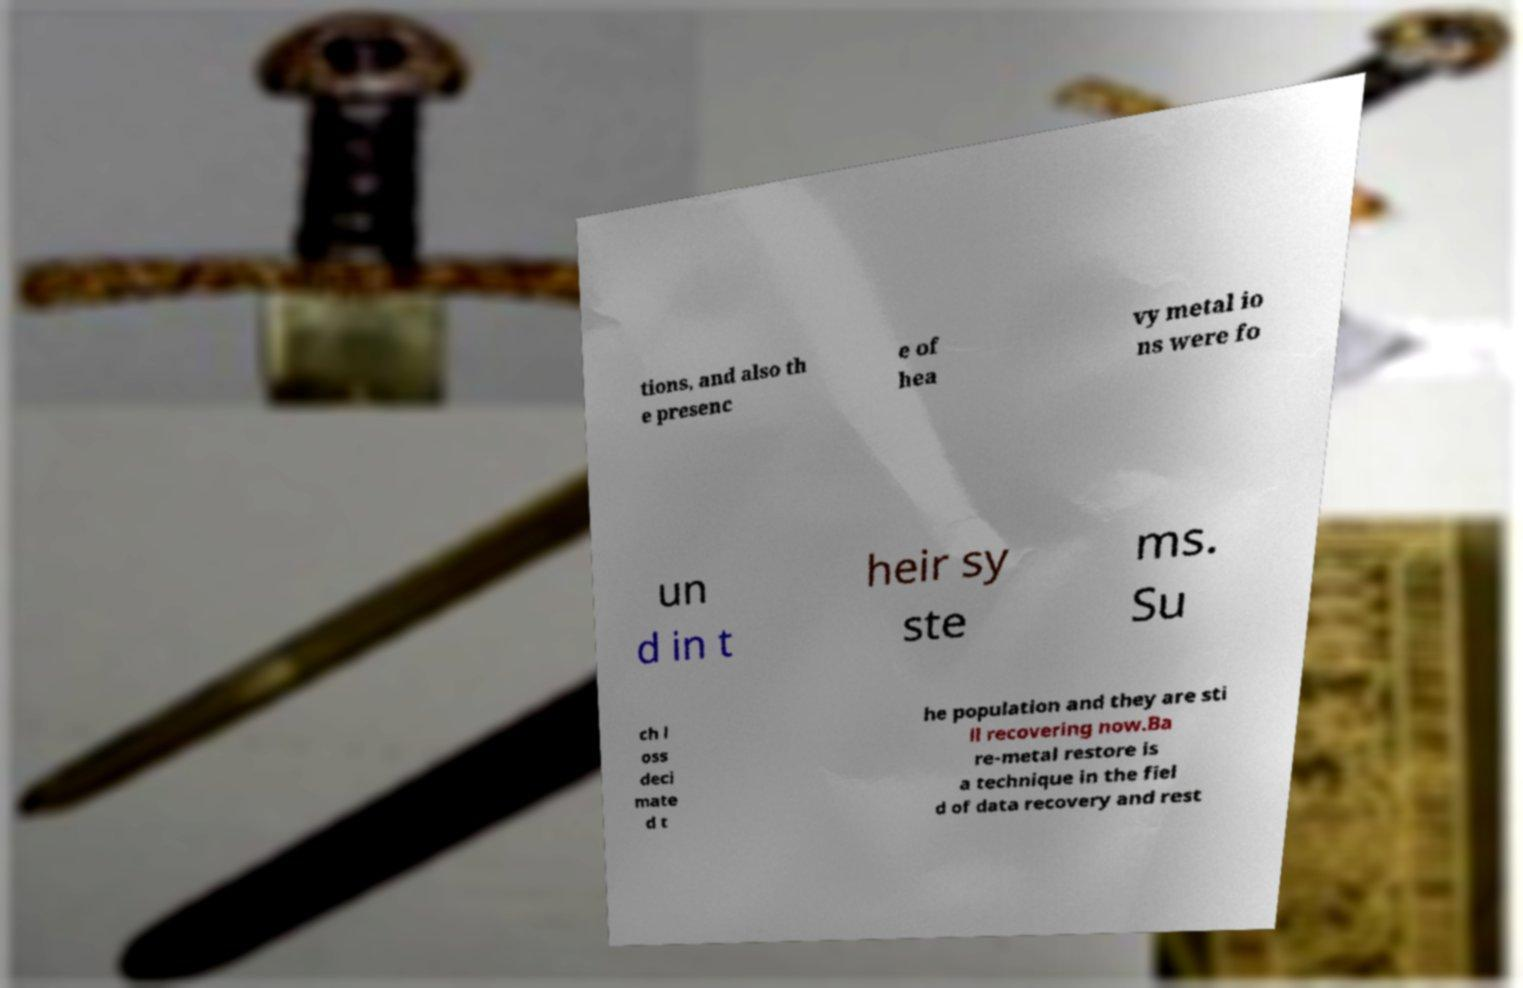I need the written content from this picture converted into text. Can you do that? tions, and also th e presenc e of hea vy metal io ns were fo un d in t heir sy ste ms. Su ch l oss deci mate d t he population and they are sti ll recovering now.Ba re-metal restore is a technique in the fiel d of data recovery and rest 